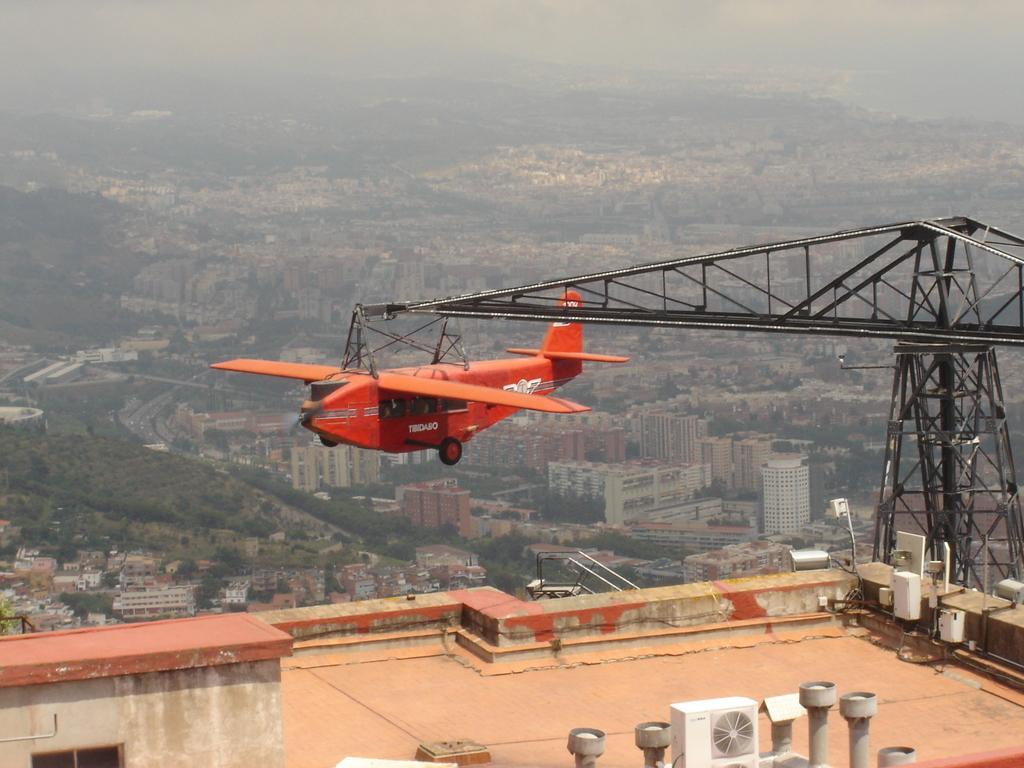Please provide a concise description of this image. In the picture I can see a plane which is attached to a rod above it and there is a building which has few objects placed on it is below it and there are few buildings and trees in the background. 